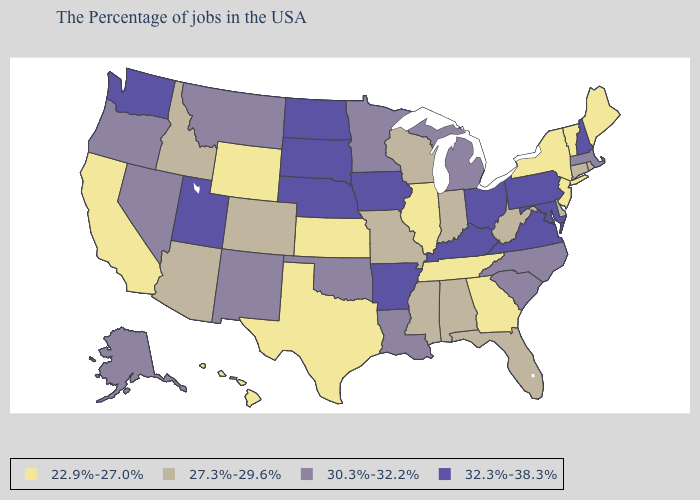Name the states that have a value in the range 22.9%-27.0%?
Concise answer only. Maine, Vermont, New York, New Jersey, Georgia, Tennessee, Illinois, Kansas, Texas, Wyoming, California, Hawaii. What is the lowest value in the MidWest?
Be succinct. 22.9%-27.0%. How many symbols are there in the legend?
Quick response, please. 4. Name the states that have a value in the range 32.3%-38.3%?
Write a very short answer. New Hampshire, Maryland, Pennsylvania, Virginia, Ohio, Kentucky, Arkansas, Iowa, Nebraska, South Dakota, North Dakota, Utah, Washington. Name the states that have a value in the range 32.3%-38.3%?
Quick response, please. New Hampshire, Maryland, Pennsylvania, Virginia, Ohio, Kentucky, Arkansas, Iowa, Nebraska, South Dakota, North Dakota, Utah, Washington. How many symbols are there in the legend?
Keep it brief. 4. Does Virginia have the highest value in the USA?
Concise answer only. Yes. Is the legend a continuous bar?
Be succinct. No. Name the states that have a value in the range 32.3%-38.3%?
Keep it brief. New Hampshire, Maryland, Pennsylvania, Virginia, Ohio, Kentucky, Arkansas, Iowa, Nebraska, South Dakota, North Dakota, Utah, Washington. Does Wisconsin have a lower value than South Dakota?
Answer briefly. Yes. Which states have the lowest value in the USA?
Give a very brief answer. Maine, Vermont, New York, New Jersey, Georgia, Tennessee, Illinois, Kansas, Texas, Wyoming, California, Hawaii. Does Kansas have the same value as Ohio?
Answer briefly. No. Name the states that have a value in the range 32.3%-38.3%?
Quick response, please. New Hampshire, Maryland, Pennsylvania, Virginia, Ohio, Kentucky, Arkansas, Iowa, Nebraska, South Dakota, North Dakota, Utah, Washington. What is the highest value in the USA?
Keep it brief. 32.3%-38.3%. What is the value of Nevada?
Quick response, please. 30.3%-32.2%. 